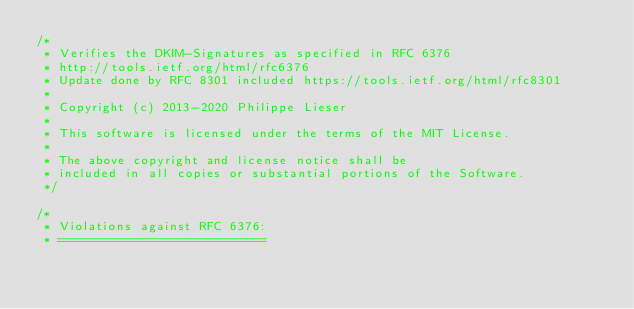<code> <loc_0><loc_0><loc_500><loc_500><_JavaScript_>/*
 * Verifies the DKIM-Signatures as specified in RFC 6376
 * http://tools.ietf.org/html/rfc6376
 * Update done by RFC 8301 included https://tools.ietf.org/html/rfc8301
 *
 * Copyright (c) 2013-2020 Philippe Lieser
 *
 * This software is licensed under the terms of the MIT License.
 *
 * The above copyright and license notice shall be
 * included in all copies or substantial portions of the Software.
 */

/*
 * Violations against RFC 6376:
 * ============================</code> 